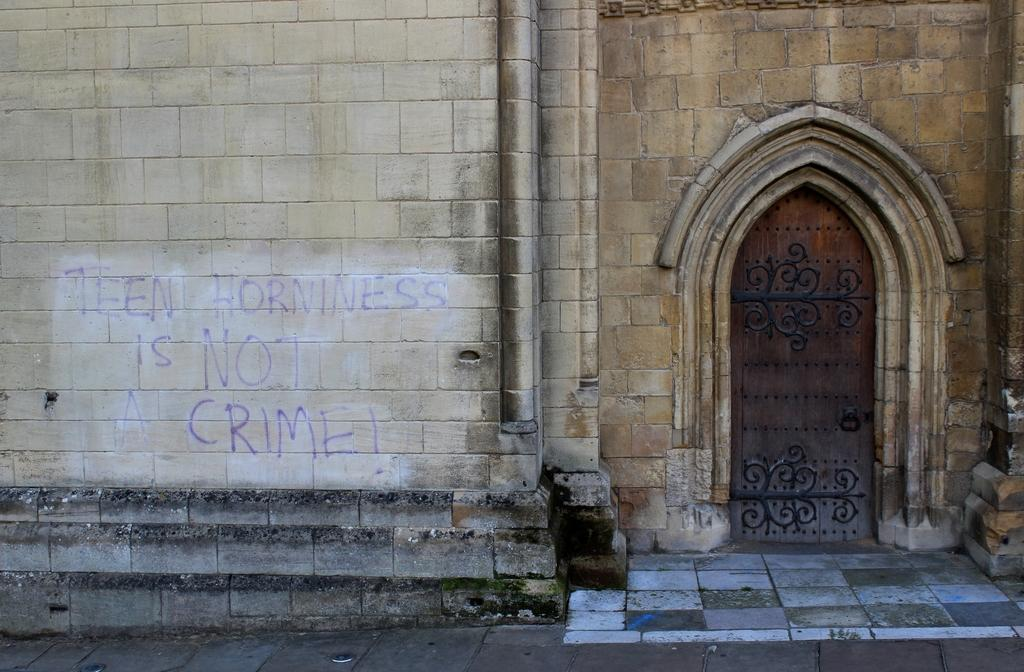What type of surface can be seen in the image? There is ground visible in the image. What structure is present in the image? There is a building in the image. What colors are used for the building? The building is cream and brown in color. What feature is present on the building? There is a door on the building. What can be seen written on the building? Something is written on the building. What type of tin can be seen hanging from the tree in the image? There is no tin or tree present in the image; it only features a building with a door and writing on it. 